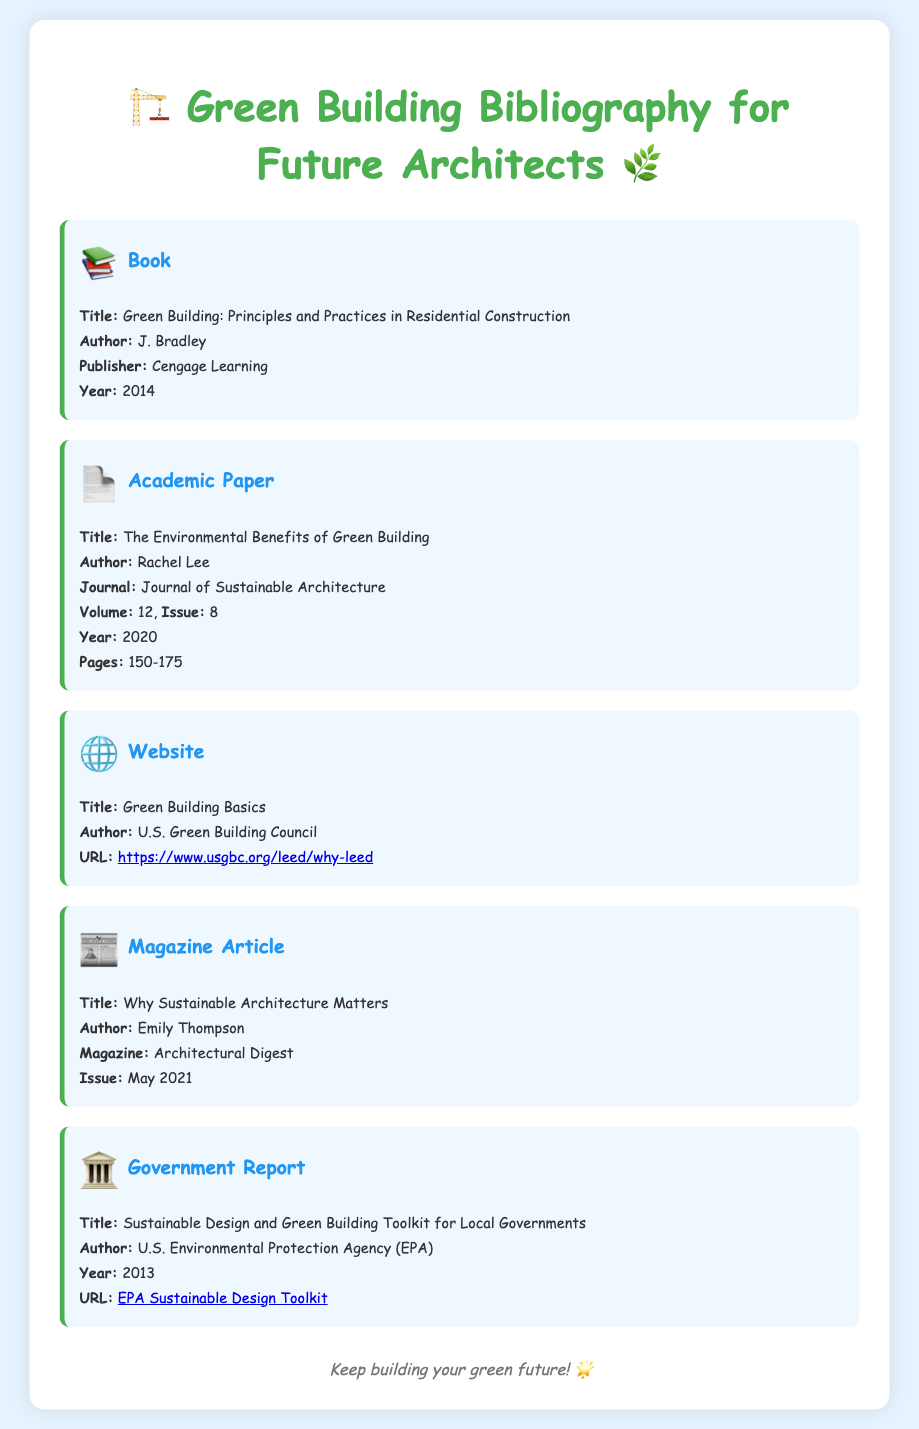What is the title of the book? The title of the book is listed in the first bibliography item.
Answer: Green Building: Principles and Practices in Residential Construction Who is the author of the academic paper? The author of the academic paper is mentioned in the second bibliography item.
Answer: Rachel Lee What year was the magazine article published? The publication year of the magazine article is specified in the fourth bibliography item.
Answer: 2021 What is the URL for the U.S. Green Building Council's website? The URL for the website is provided in the third bibliography item.
Answer: https://www.usgbc.org/leed/why-leed Which organization published the government report? The publisher of the government report is indicated in the fifth bibliography item.
Answer: U.S. Environmental Protection Agency (EPA) What type of document is "Green Building: Principles and Practices in Residential Construction"? This information is found in the first bibliography item's type.
Answer: Book How many pages does the academic paper span? The number of pages for the academic paper is found in the second bibliography item.
Answer: 150-175 What is the name of the magazine where the article was published? The magazine name is included in the fourth bibliography item.
Answer: Architectural Digest What is the volume number of the journal for the academic paper? The volume number is provided in the second bibliography item.
Answer: 12 